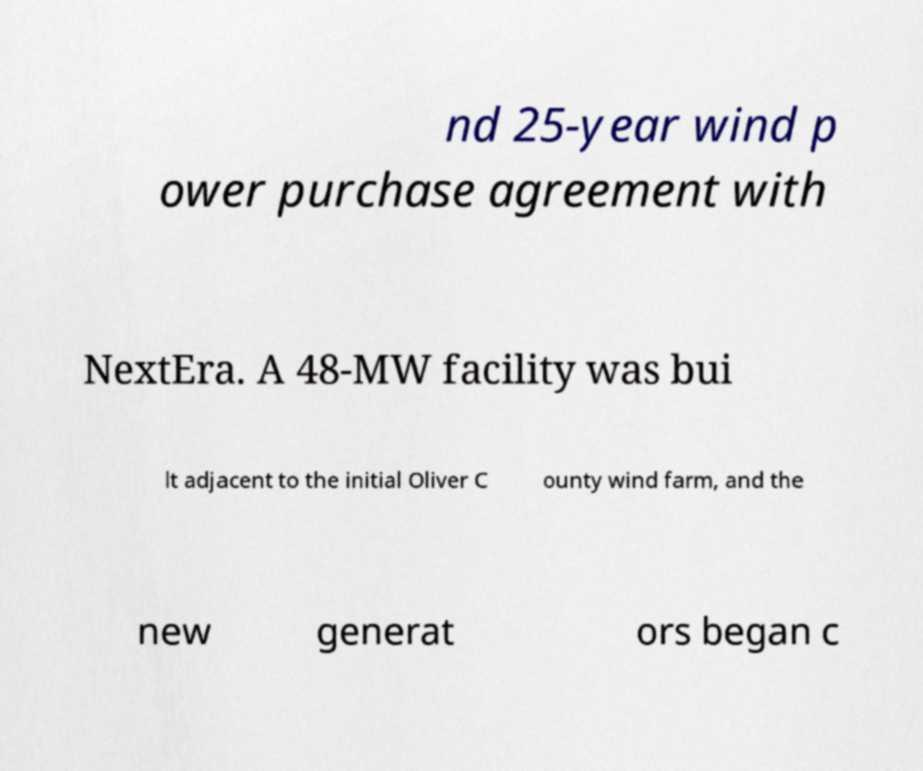Please identify and transcribe the text found in this image. nd 25-year wind p ower purchase agreement with NextEra. A 48-MW facility was bui lt adjacent to the initial Oliver C ounty wind farm, and the new generat ors began c 